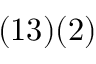Convert formula to latex. <formula><loc_0><loc_0><loc_500><loc_500>( { 1 3 } ) ( { 2 } )</formula> 